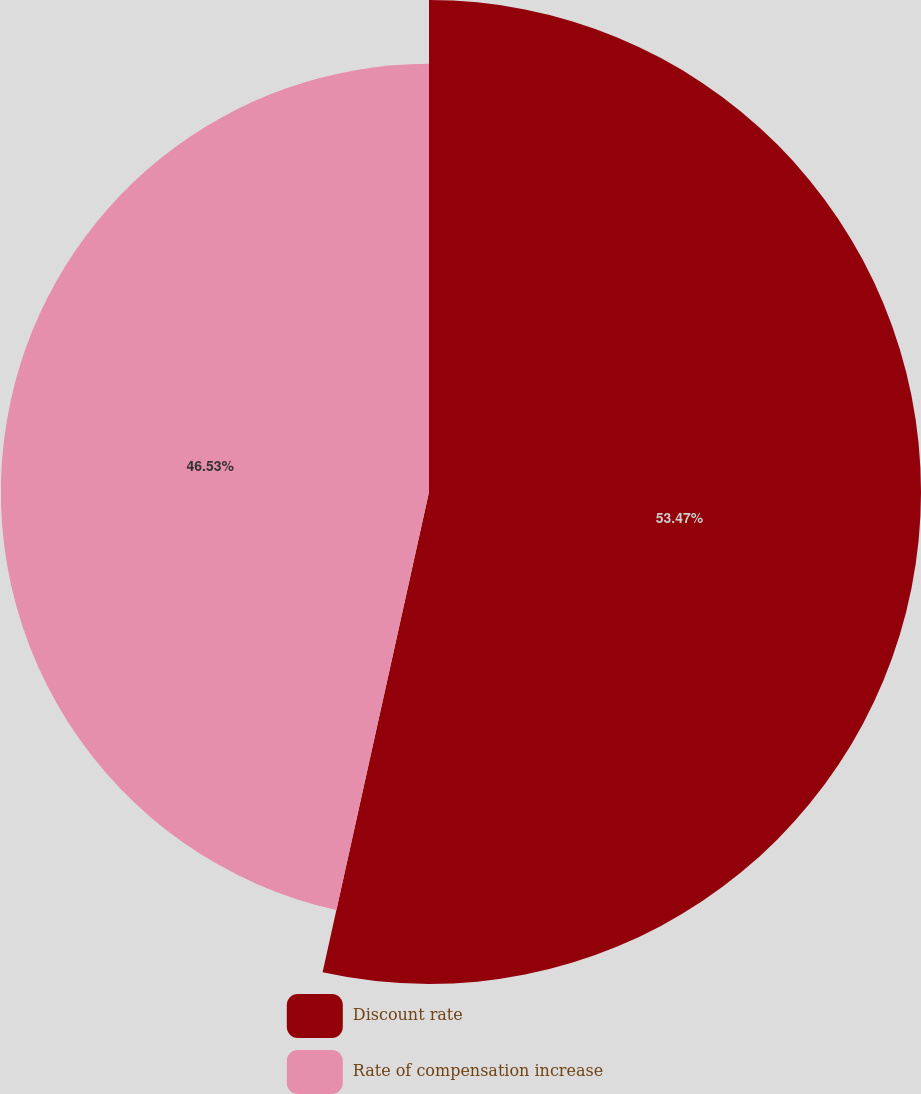Convert chart to OTSL. <chart><loc_0><loc_0><loc_500><loc_500><pie_chart><fcel>Discount rate<fcel>Rate of compensation increase<nl><fcel>53.47%<fcel>46.53%<nl></chart> 